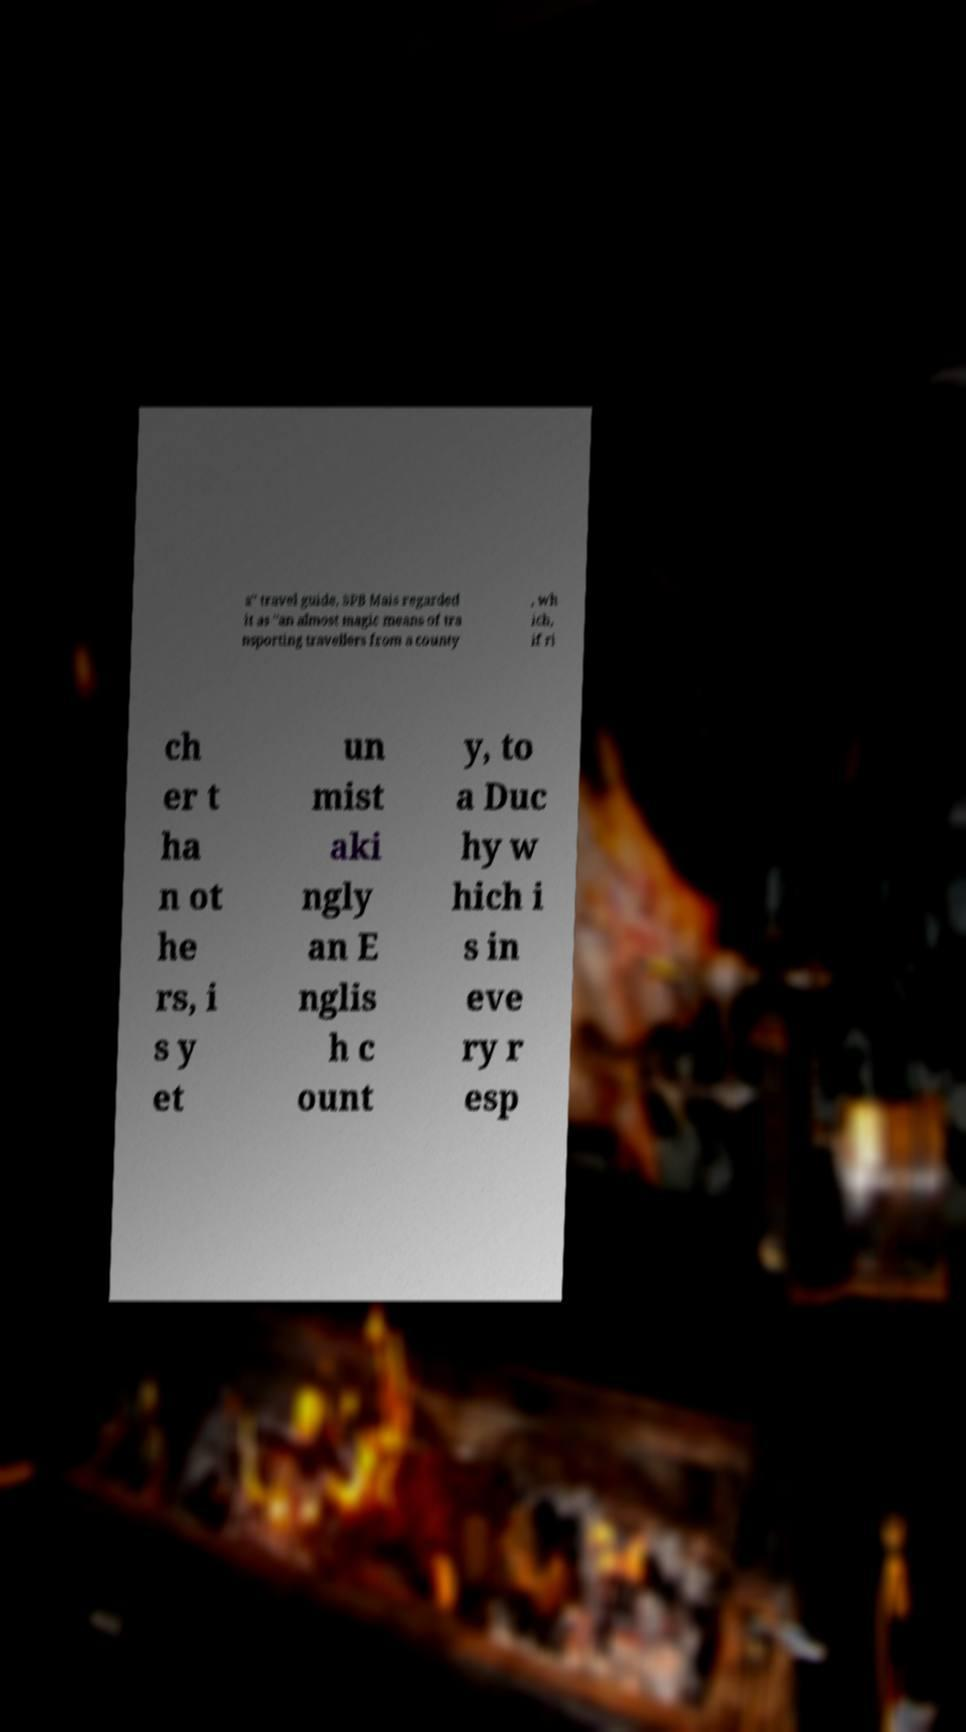What messages or text are displayed in this image? I need them in a readable, typed format. a" travel guide, SPB Mais regarded it as "an almost magic means of tra nsporting travellers from a county , wh ich, if ri ch er t ha n ot he rs, i s y et un mist aki ngly an E nglis h c ount y, to a Duc hy w hich i s in eve ry r esp 